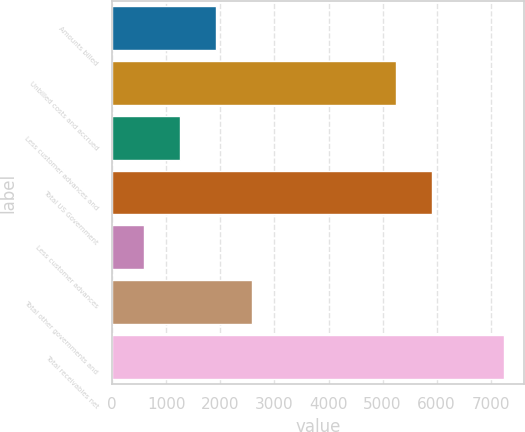Convert chart to OTSL. <chart><loc_0><loc_0><loc_500><loc_500><bar_chart><fcel>Amounts billed<fcel>Unbilled costs and accrued<fcel>Less customer advances and<fcel>Total US Government<fcel>Less customer advances<fcel>Total other governments and<fcel>Total receivables net<nl><fcel>1925.2<fcel>5243<fcel>1259.1<fcel>5909.1<fcel>593<fcel>2591.3<fcel>7254<nl></chart> 